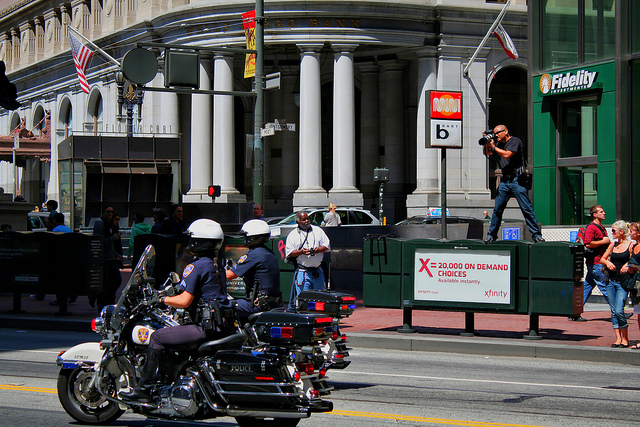Identify the text contained in this image. X 20,000 ON DEMAND CHOICES xfinity 6418 Fidelity b 